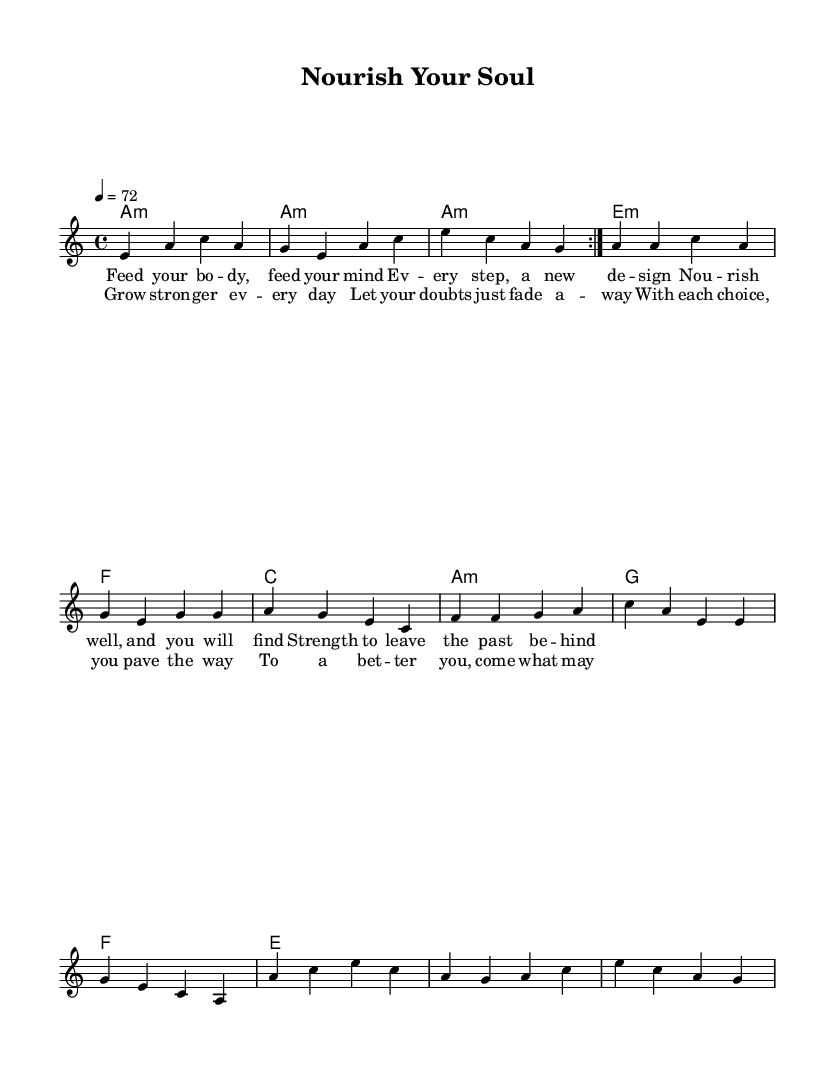What is the key signature of this music? The key signature is indicated at the beginning of the sheet music. It shows that the music is in A minor, which has no sharps or flats.
Answer: A minor What is the time signature of the piece? The time signature, also located at the beginning of the sheet music, is shown as 4/4, meaning there are 4 beats in each measure and a quarter note gets one beat.
Answer: 4/4 What is the tempo marking for this piece? The tempo marking is found above the staff and is indicated as 4 equals 72, denoting that the piece should be played at a speed of 72 beats per minute, with a quarter note receiving one beat.
Answer: 72 How many times is the first section repeated? The sheet music indicates a repeat sign before the first section and states "volta 2," which means that this section is intended to be played twice.
Answer: 2 What chord does the piece start with? The first chord in the chord progression is represented at the beginning of the harmonies section. It is written as A minor, indicating the tonal foundation of the piece.
Answer: A minor What lyrical theme is presented in the chorus? Analyzing the lyrics of the chorus, it emphasizes personal growth and perseverance, indicating that with each choice made, an individual paves the way for improvement and strength.
Answer: Personal growth How does the structure reflect typical blues elements? This piece features a repetitive chord structure and lyrical phrasing, common in blues music, particularly focusing on themes of resilience and inner strength, which mirrors traditional blues characteristics.
Answer: Repetitive structure 